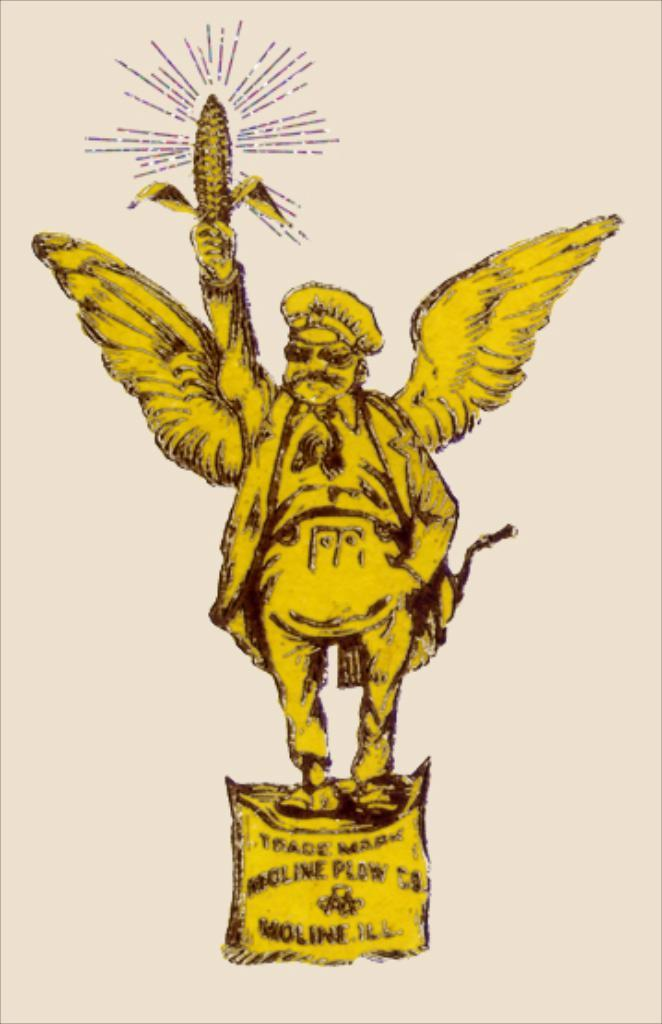What is depicted in the image? There is a drawing of a person in the image. What can be said about the color of the drawing? The drawing is yellow in color. What type of amusement can be seen in the drawing? There is no amusement depicted in the drawing, as it is a simple drawing of a person. What kind of egg is being used in the protest shown in the image? There is no protest or egg present in the image; it only features a yellow drawing of a person. 